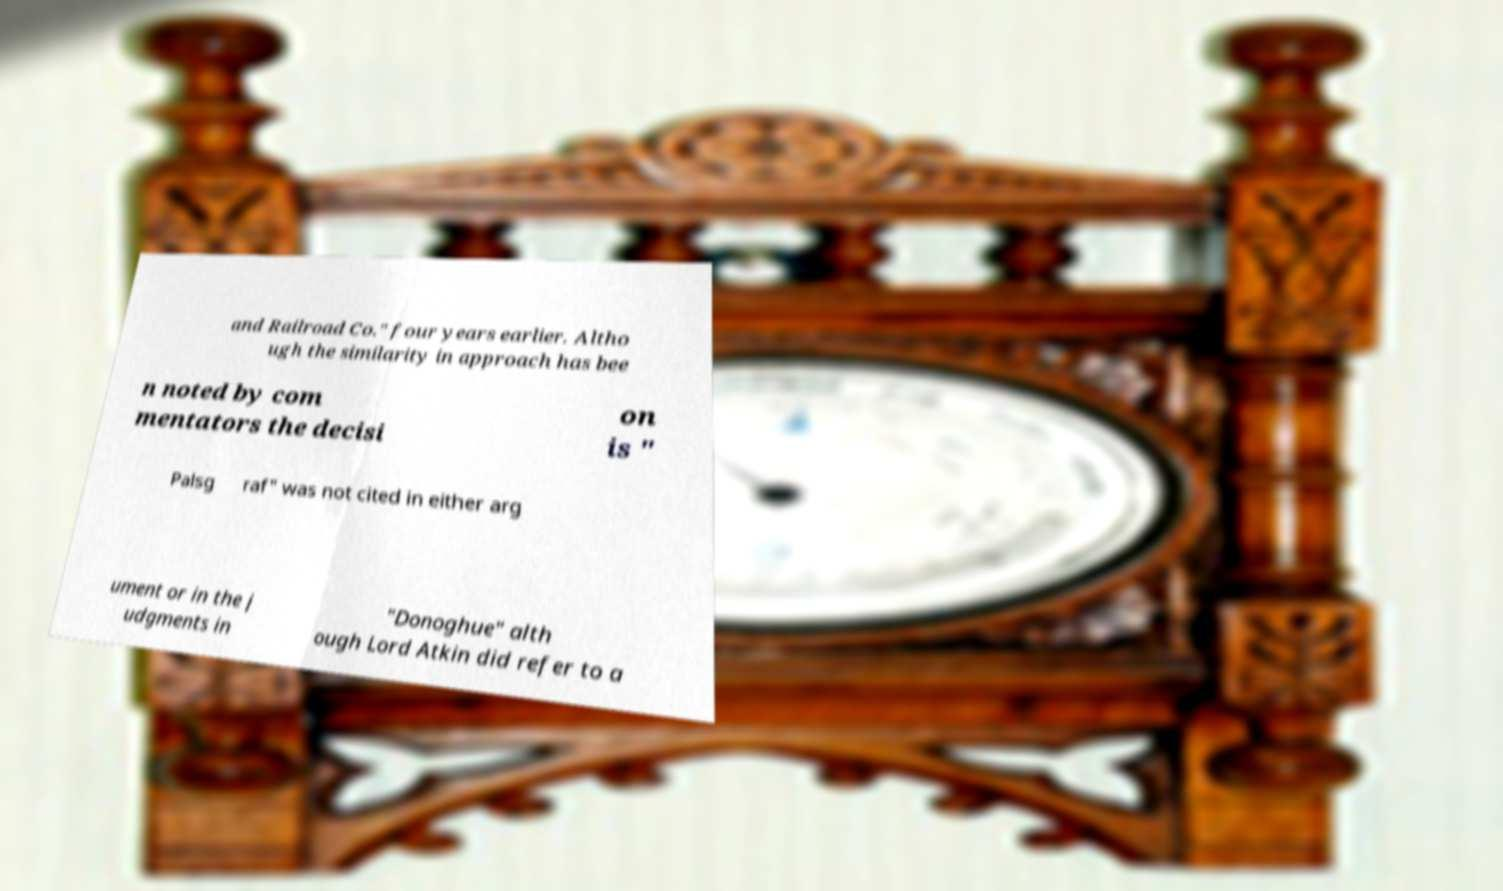Please identify and transcribe the text found in this image. and Railroad Co." four years earlier. Altho ugh the similarity in approach has bee n noted by com mentators the decisi on is " Palsg raf" was not cited in either arg ument or in the j udgments in "Donoghue" alth ough Lord Atkin did refer to a 